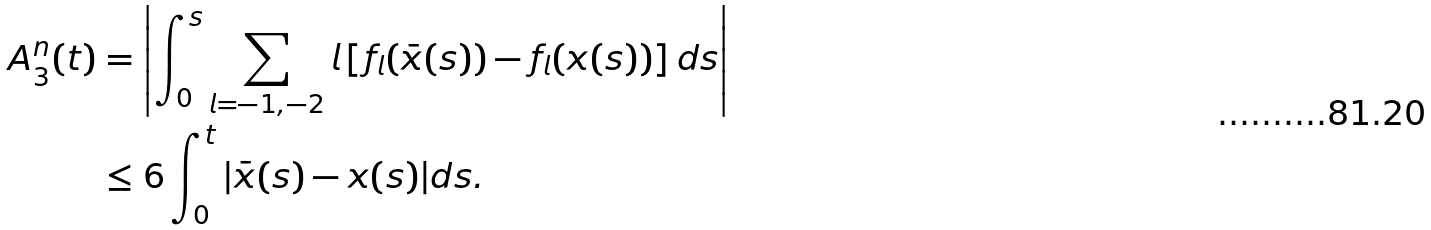Convert formula to latex. <formula><loc_0><loc_0><loc_500><loc_500>A _ { 3 } ^ { n } ( t ) & = \left | \int _ { 0 } ^ { s } \sum _ { l = - 1 , - 2 } l \left [ f _ { l } ( \bar { x } ( s ) ) - f _ { l } ( x ( s ) ) \right ] d s \right | \\ & \leq 6 \int _ { 0 } ^ { t } | \bar { x } ( s ) - x ( s ) | d s .</formula> 